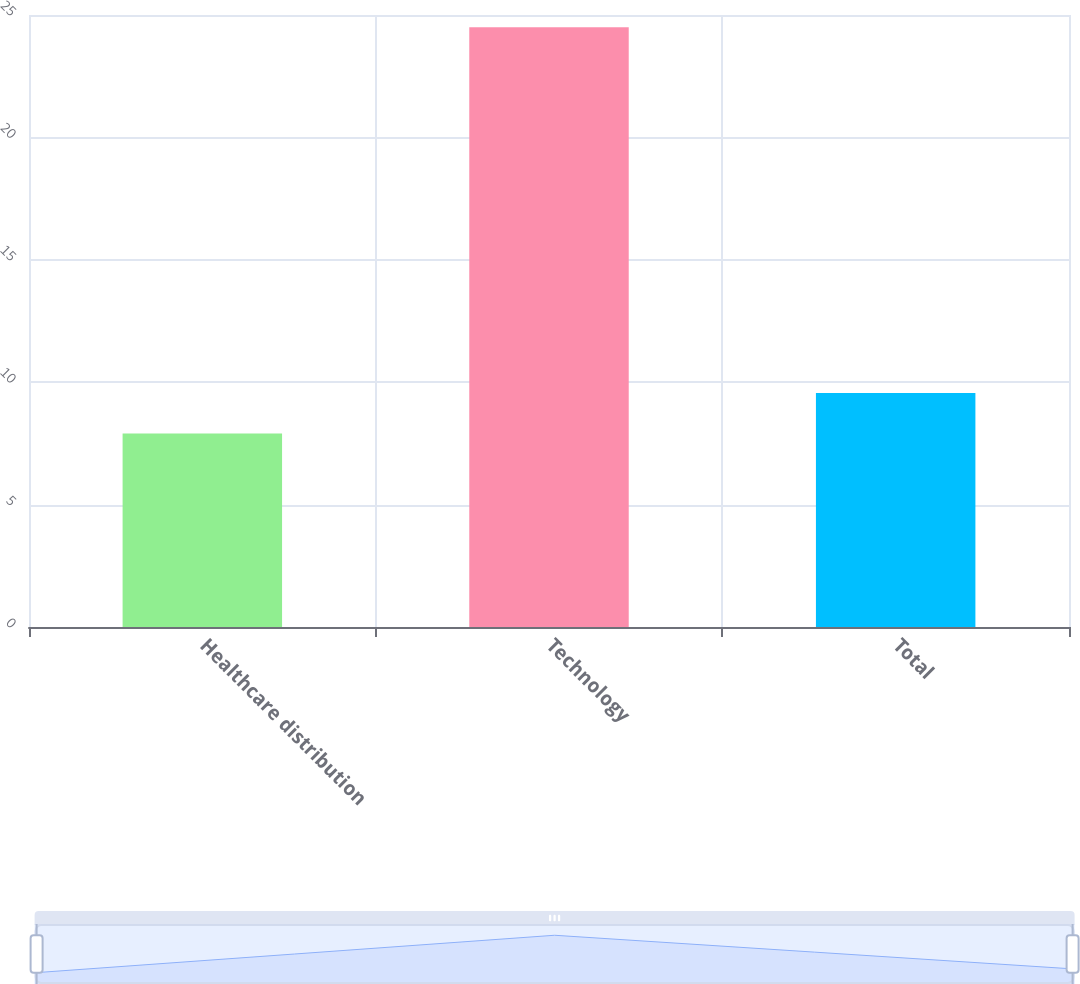<chart> <loc_0><loc_0><loc_500><loc_500><bar_chart><fcel>Healthcare distribution<fcel>Technology<fcel>Total<nl><fcel>7.9<fcel>24.5<fcel>9.56<nl></chart> 